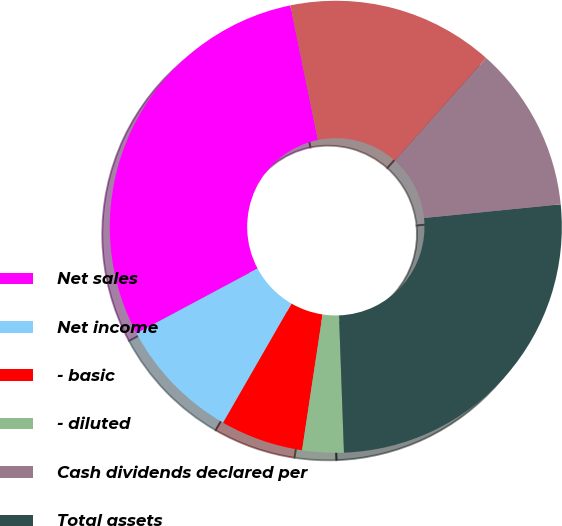Convert chart. <chart><loc_0><loc_0><loc_500><loc_500><pie_chart><fcel>Net sales<fcel>Net income<fcel>- basic<fcel>- diluted<fcel>Cash dividends declared per<fcel>Total assets<fcel>Total debt obligations(1)<fcel>Stockholders' equity<nl><fcel>29.59%<fcel>8.88%<fcel>5.92%<fcel>2.96%<fcel>0.0%<fcel>26.01%<fcel>11.84%<fcel>14.8%<nl></chart> 